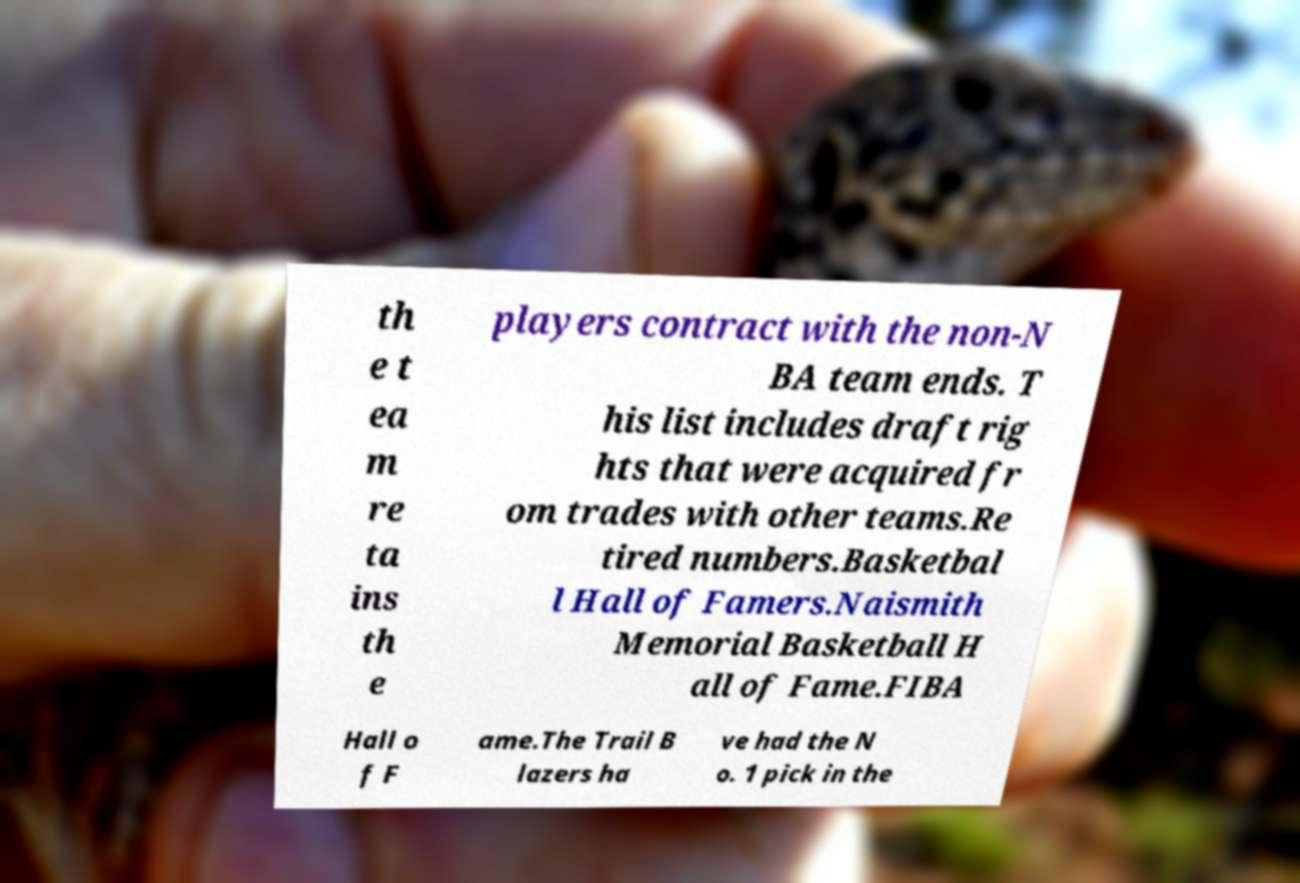Please read and relay the text visible in this image. What does it say? th e t ea m re ta ins th e players contract with the non-N BA team ends. T his list includes draft rig hts that were acquired fr om trades with other teams.Re tired numbers.Basketbal l Hall of Famers.Naismith Memorial Basketball H all of Fame.FIBA Hall o f F ame.The Trail B lazers ha ve had the N o. 1 pick in the 